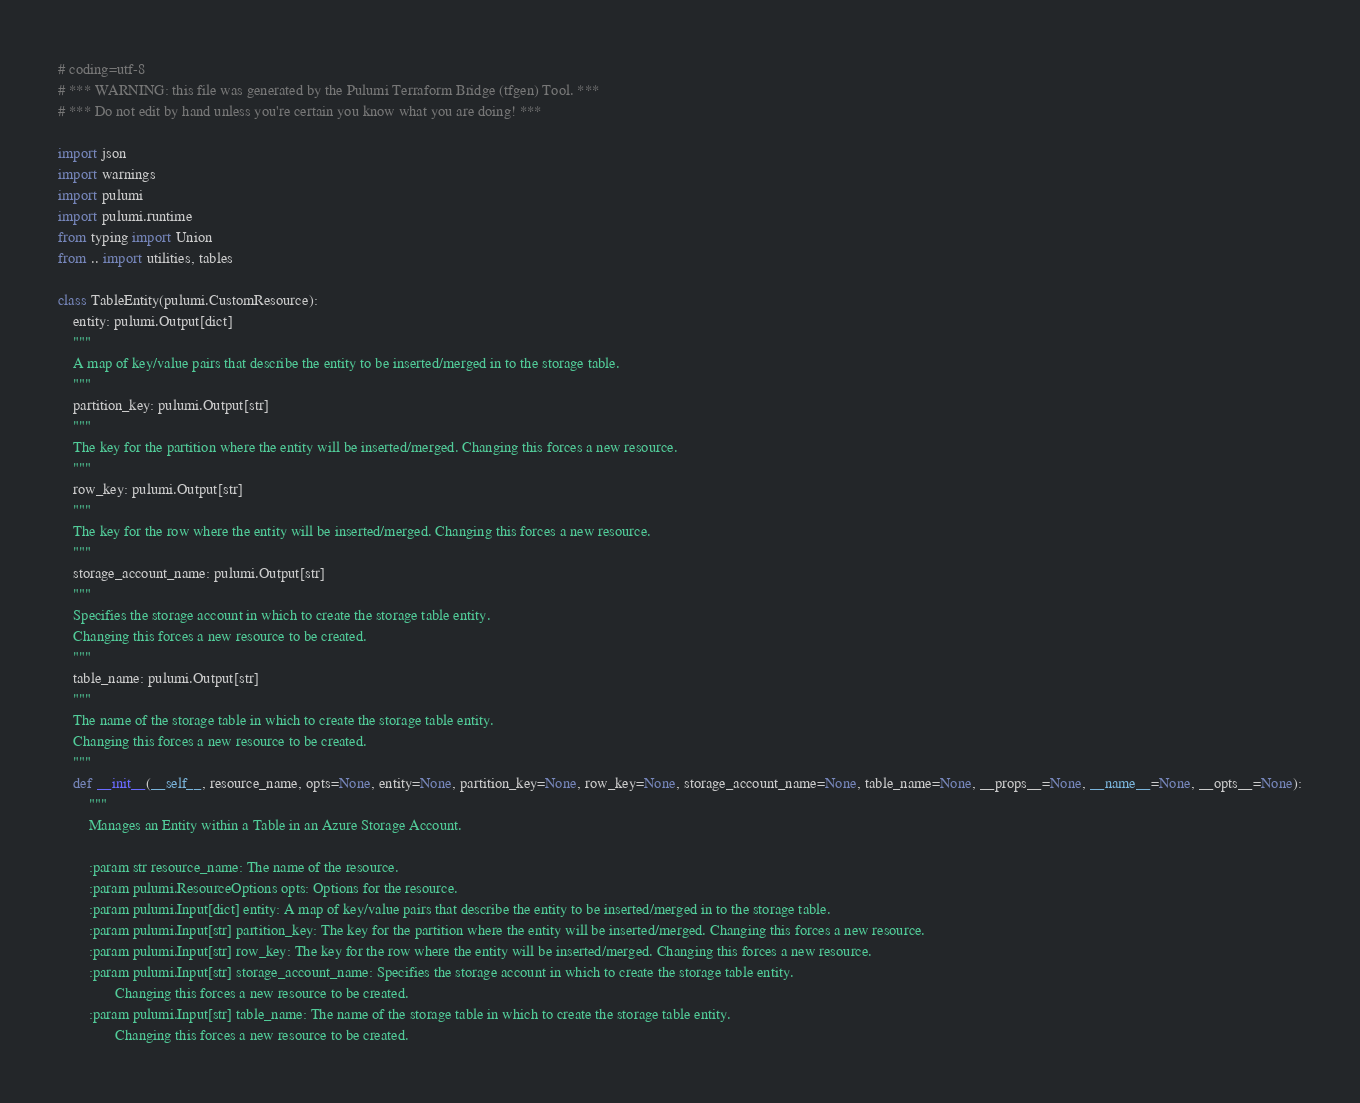<code> <loc_0><loc_0><loc_500><loc_500><_Python_># coding=utf-8
# *** WARNING: this file was generated by the Pulumi Terraform Bridge (tfgen) Tool. ***
# *** Do not edit by hand unless you're certain you know what you are doing! ***

import json
import warnings
import pulumi
import pulumi.runtime
from typing import Union
from .. import utilities, tables

class TableEntity(pulumi.CustomResource):
    entity: pulumi.Output[dict]
    """
    A map of key/value pairs that describe the entity to be inserted/merged in to the storage table.
    """
    partition_key: pulumi.Output[str]
    """
    The key for the partition where the entity will be inserted/merged. Changing this forces a new resource.
    """
    row_key: pulumi.Output[str]
    """
    The key for the row where the entity will be inserted/merged. Changing this forces a new resource.
    """
    storage_account_name: pulumi.Output[str]
    """
    Specifies the storage account in which to create the storage table entity.
    Changing this forces a new resource to be created.
    """
    table_name: pulumi.Output[str]
    """
    The name of the storage table in which to create the storage table entity.
    Changing this forces a new resource to be created.
    """
    def __init__(__self__, resource_name, opts=None, entity=None, partition_key=None, row_key=None, storage_account_name=None, table_name=None, __props__=None, __name__=None, __opts__=None):
        """
        Manages an Entity within a Table in an Azure Storage Account.
        
        :param str resource_name: The name of the resource.
        :param pulumi.ResourceOptions opts: Options for the resource.
        :param pulumi.Input[dict] entity: A map of key/value pairs that describe the entity to be inserted/merged in to the storage table.
        :param pulumi.Input[str] partition_key: The key for the partition where the entity will be inserted/merged. Changing this forces a new resource.
        :param pulumi.Input[str] row_key: The key for the row where the entity will be inserted/merged. Changing this forces a new resource.
        :param pulumi.Input[str] storage_account_name: Specifies the storage account in which to create the storage table entity.
               Changing this forces a new resource to be created.
        :param pulumi.Input[str] table_name: The name of the storage table in which to create the storage table entity.
               Changing this forces a new resource to be created.
</code> 